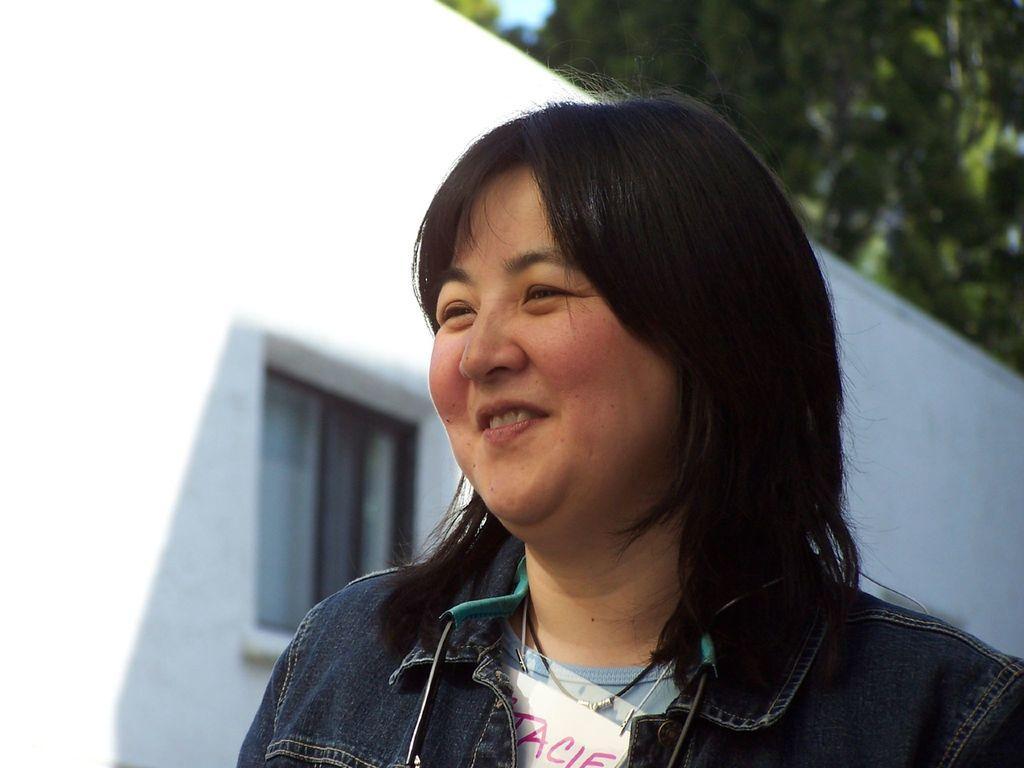Could you give a brief overview of what you see in this image? The woman in front of the picture wearing blue T-shirt and blue jacket is smiling. Behind her, we see windows and a building in white color. In the background, there are trees. 